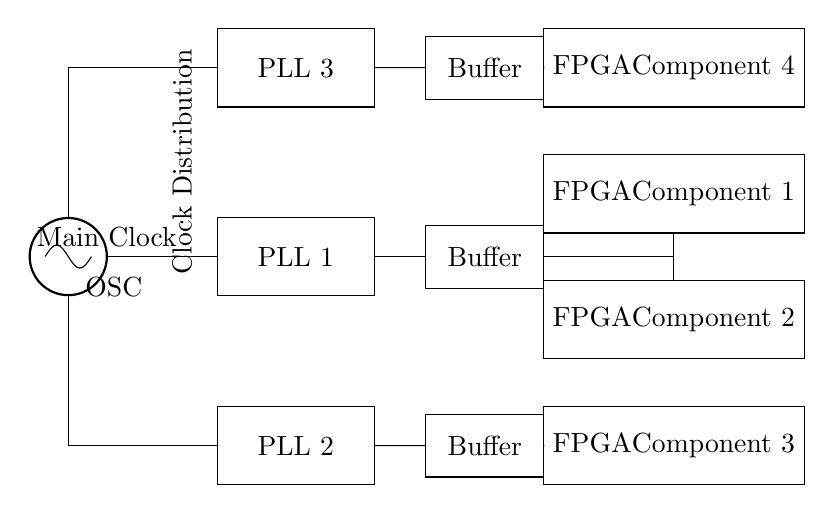What type of circuit is this? This is a clock distribution network utilizing multiple phase-locked loops. The presence of an oscillator and several PLLs indicates its function for synchronizing the clock signals across different components.
Answer: Clock distribution network How many phase-locked loops are shown? There are three phase-locked loops represented in the circuit diagram, labeled PLL 1, PLL 2, and PLL 3. Each PLL is a separate component connected to the main clock source.
Answer: Three What is the purpose of the buffers in this circuit? The buffers serve to strengthen the clock signals coming from the PLLs before they are sent to the FPGA components, ensuring signal integrity and reducing time delays.
Answer: Strengthen clock signals Which component receives the main clock? The oscillator (labeled OSC) is the component that receives and generates the main clock signal, which is then distributed to the PLLs and buffers.
Answer: Oscillator What is the relationship between the PLLs and the FPGA components? Each PLL connects to a buffer, which in turn distributes the clock signal to specific FPGA components, implying that PLLs are essential for generating synchronized clock signals for the FPGA architecture.
Answer: Synchronized clock signals Which FPGA component does not receive a clock signal directly from a buffer? FPGA Component 2 does not receive a clock signal directly; it is connected to Buffer 1, which is fed by PLL 1. The other FPGA components are connected directly to their respective buffers after the PLLs.
Answer: FPGA Component 2 